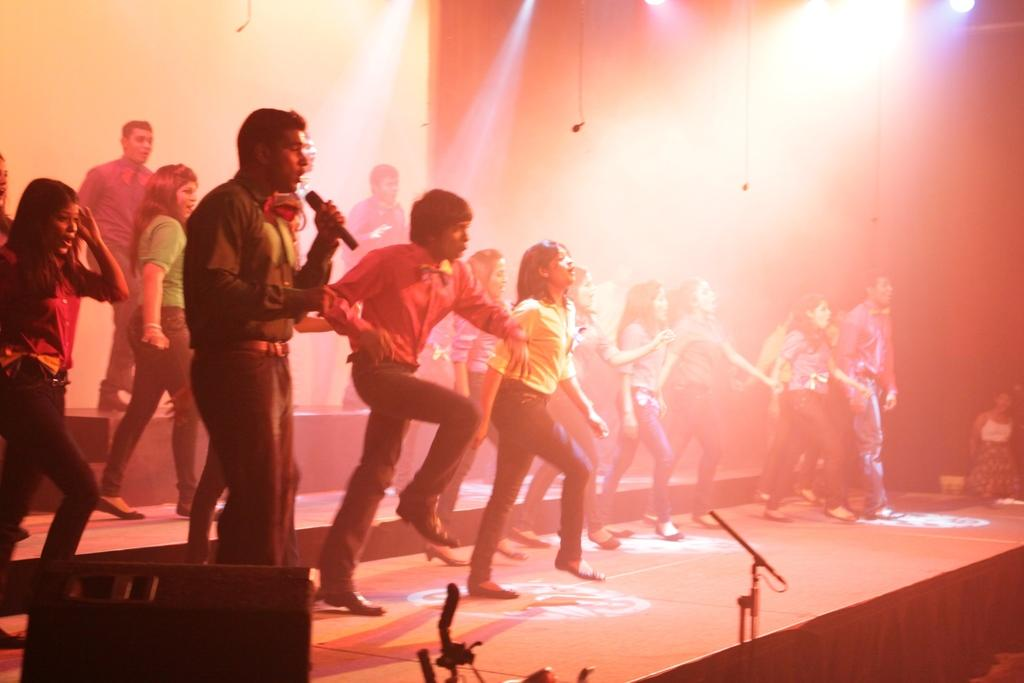What are the people in the image doing? There is a group of persons dancing in the image. Where is the dancing taking place? The dancing is taking place on the floor. What equipment can be seen at the bottom of the image? There is a speaker and a mic stand at the bottom of the image. What can be seen in the background of the image? There are lights, a screen, and a wall in the background of the image. How many pizzas are being served to the dancers in the image? There are no pizzas present in the image; it features a group of people dancing with a speaker and a mic stand at the bottom. Can you see a duck in the image? There is no duck present in the image. 